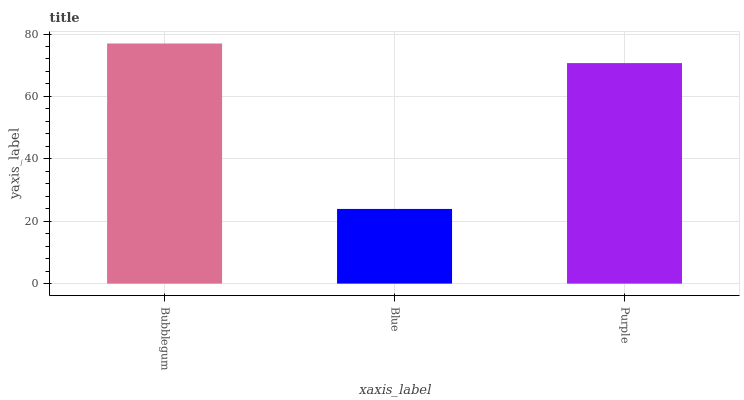Is Blue the minimum?
Answer yes or no. Yes. Is Bubblegum the maximum?
Answer yes or no. Yes. Is Purple the minimum?
Answer yes or no. No. Is Purple the maximum?
Answer yes or no. No. Is Purple greater than Blue?
Answer yes or no. Yes. Is Blue less than Purple?
Answer yes or no. Yes. Is Blue greater than Purple?
Answer yes or no. No. Is Purple less than Blue?
Answer yes or no. No. Is Purple the high median?
Answer yes or no. Yes. Is Purple the low median?
Answer yes or no. Yes. Is Blue the high median?
Answer yes or no. No. Is Bubblegum the low median?
Answer yes or no. No. 